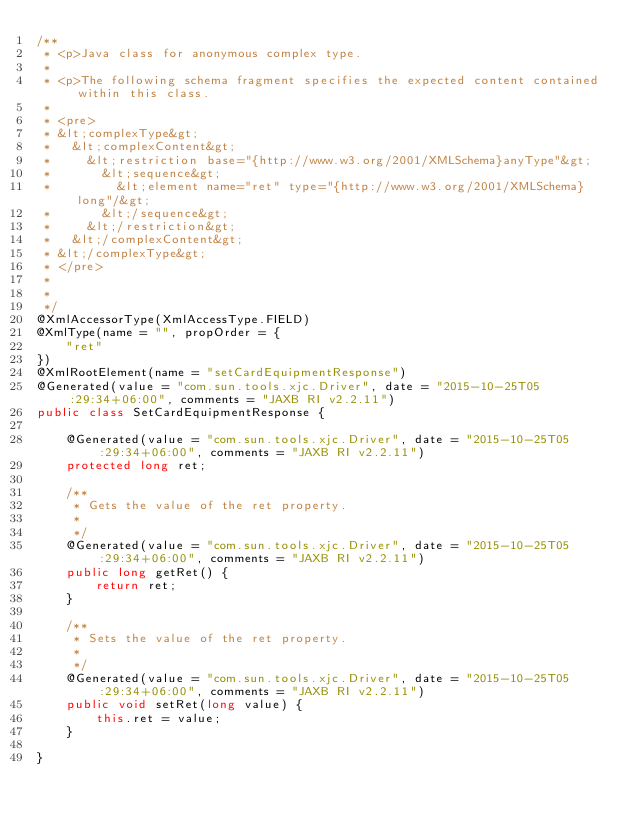Convert code to text. <code><loc_0><loc_0><loc_500><loc_500><_Java_>/**
 * <p>Java class for anonymous complex type.
 * 
 * <p>The following schema fragment specifies the expected content contained within this class.
 * 
 * <pre>
 * &lt;complexType&gt;
 *   &lt;complexContent&gt;
 *     &lt;restriction base="{http://www.w3.org/2001/XMLSchema}anyType"&gt;
 *       &lt;sequence&gt;
 *         &lt;element name="ret" type="{http://www.w3.org/2001/XMLSchema}long"/&gt;
 *       &lt;/sequence&gt;
 *     &lt;/restriction&gt;
 *   &lt;/complexContent&gt;
 * &lt;/complexType&gt;
 * </pre>
 * 
 * 
 */
@XmlAccessorType(XmlAccessType.FIELD)
@XmlType(name = "", propOrder = {
    "ret"
})
@XmlRootElement(name = "setCardEquipmentResponse")
@Generated(value = "com.sun.tools.xjc.Driver", date = "2015-10-25T05:29:34+06:00", comments = "JAXB RI v2.2.11")
public class SetCardEquipmentResponse {

    @Generated(value = "com.sun.tools.xjc.Driver", date = "2015-10-25T05:29:34+06:00", comments = "JAXB RI v2.2.11")
    protected long ret;

    /**
     * Gets the value of the ret property.
     * 
     */
    @Generated(value = "com.sun.tools.xjc.Driver", date = "2015-10-25T05:29:34+06:00", comments = "JAXB RI v2.2.11")
    public long getRet() {
        return ret;
    }

    /**
     * Sets the value of the ret property.
     * 
     */
    @Generated(value = "com.sun.tools.xjc.Driver", date = "2015-10-25T05:29:34+06:00", comments = "JAXB RI v2.2.11")
    public void setRet(long value) {
        this.ret = value;
    }

}
</code> 